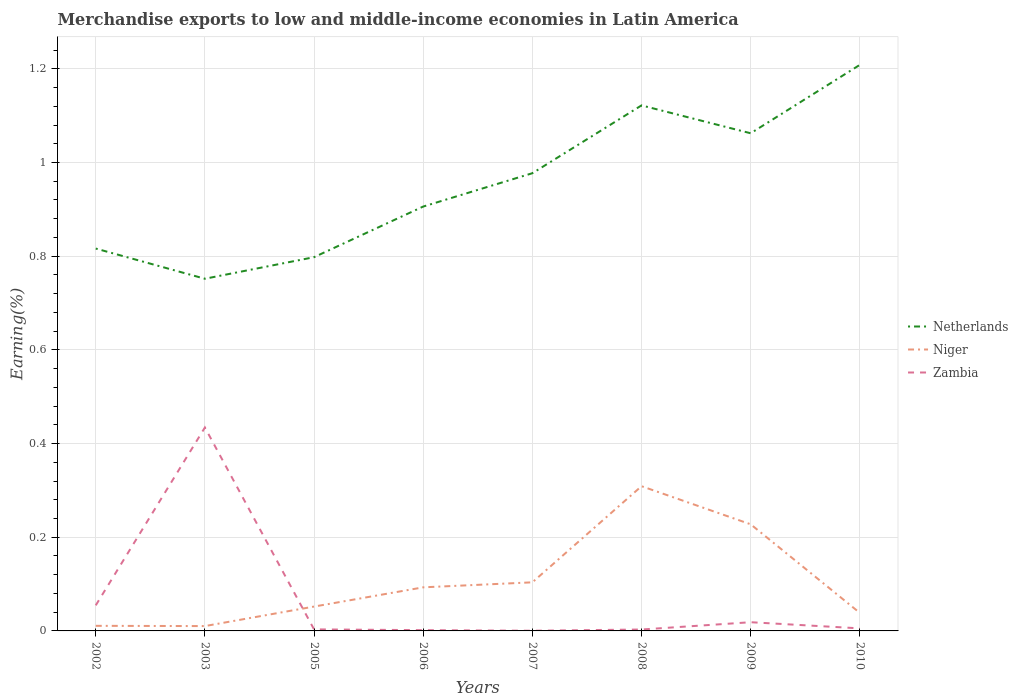Across all years, what is the maximum percentage of amount earned from merchandise exports in Zambia?
Provide a succinct answer. 0. What is the total percentage of amount earned from merchandise exports in Zambia in the graph?
Provide a short and direct response. 0.01. What is the difference between the highest and the second highest percentage of amount earned from merchandise exports in Netherlands?
Your answer should be compact. 0.46. What is the difference between the highest and the lowest percentage of amount earned from merchandise exports in Netherlands?
Your answer should be compact. 4. Is the percentage of amount earned from merchandise exports in Niger strictly greater than the percentage of amount earned from merchandise exports in Netherlands over the years?
Your response must be concise. Yes. How many lines are there?
Your answer should be very brief. 3. What is the difference between two consecutive major ticks on the Y-axis?
Give a very brief answer. 0.2. Does the graph contain grids?
Your answer should be compact. Yes. Where does the legend appear in the graph?
Offer a terse response. Center right. How are the legend labels stacked?
Offer a very short reply. Vertical. What is the title of the graph?
Your answer should be very brief. Merchandise exports to low and middle-income economies in Latin America. What is the label or title of the X-axis?
Make the answer very short. Years. What is the label or title of the Y-axis?
Offer a terse response. Earning(%). What is the Earning(%) in Netherlands in 2002?
Ensure brevity in your answer.  0.82. What is the Earning(%) in Niger in 2002?
Your response must be concise. 0.01. What is the Earning(%) in Zambia in 2002?
Ensure brevity in your answer.  0.05. What is the Earning(%) in Netherlands in 2003?
Offer a terse response. 0.75. What is the Earning(%) in Niger in 2003?
Ensure brevity in your answer.  0.01. What is the Earning(%) in Zambia in 2003?
Ensure brevity in your answer.  0.43. What is the Earning(%) in Netherlands in 2005?
Give a very brief answer. 0.8. What is the Earning(%) of Niger in 2005?
Ensure brevity in your answer.  0.05. What is the Earning(%) in Zambia in 2005?
Give a very brief answer. 0. What is the Earning(%) in Netherlands in 2006?
Your answer should be compact. 0.91. What is the Earning(%) in Niger in 2006?
Your answer should be compact. 0.09. What is the Earning(%) in Zambia in 2006?
Your answer should be compact. 0. What is the Earning(%) in Netherlands in 2007?
Make the answer very short. 0.98. What is the Earning(%) of Niger in 2007?
Ensure brevity in your answer.  0.1. What is the Earning(%) of Zambia in 2007?
Ensure brevity in your answer.  0. What is the Earning(%) in Netherlands in 2008?
Provide a short and direct response. 1.12. What is the Earning(%) in Niger in 2008?
Keep it short and to the point. 0.31. What is the Earning(%) of Zambia in 2008?
Ensure brevity in your answer.  0. What is the Earning(%) in Netherlands in 2009?
Offer a very short reply. 1.06. What is the Earning(%) of Niger in 2009?
Give a very brief answer. 0.23. What is the Earning(%) in Zambia in 2009?
Keep it short and to the point. 0.02. What is the Earning(%) in Netherlands in 2010?
Give a very brief answer. 1.21. What is the Earning(%) of Niger in 2010?
Your response must be concise. 0.04. What is the Earning(%) of Zambia in 2010?
Offer a terse response. 0.01. Across all years, what is the maximum Earning(%) of Netherlands?
Offer a very short reply. 1.21. Across all years, what is the maximum Earning(%) of Niger?
Give a very brief answer. 0.31. Across all years, what is the maximum Earning(%) in Zambia?
Make the answer very short. 0.43. Across all years, what is the minimum Earning(%) of Netherlands?
Provide a short and direct response. 0.75. Across all years, what is the minimum Earning(%) in Niger?
Offer a terse response. 0.01. Across all years, what is the minimum Earning(%) in Zambia?
Offer a very short reply. 0. What is the total Earning(%) in Netherlands in the graph?
Your answer should be compact. 7.64. What is the total Earning(%) in Niger in the graph?
Keep it short and to the point. 0.85. What is the total Earning(%) of Zambia in the graph?
Ensure brevity in your answer.  0.52. What is the difference between the Earning(%) of Netherlands in 2002 and that in 2003?
Provide a short and direct response. 0.06. What is the difference between the Earning(%) of Zambia in 2002 and that in 2003?
Offer a terse response. -0.38. What is the difference between the Earning(%) in Netherlands in 2002 and that in 2005?
Make the answer very short. 0.02. What is the difference between the Earning(%) of Niger in 2002 and that in 2005?
Ensure brevity in your answer.  -0.04. What is the difference between the Earning(%) of Zambia in 2002 and that in 2005?
Your response must be concise. 0.05. What is the difference between the Earning(%) in Netherlands in 2002 and that in 2006?
Make the answer very short. -0.09. What is the difference between the Earning(%) in Niger in 2002 and that in 2006?
Give a very brief answer. -0.08. What is the difference between the Earning(%) in Zambia in 2002 and that in 2006?
Keep it short and to the point. 0.05. What is the difference between the Earning(%) of Netherlands in 2002 and that in 2007?
Your answer should be very brief. -0.16. What is the difference between the Earning(%) of Niger in 2002 and that in 2007?
Your response must be concise. -0.09. What is the difference between the Earning(%) in Zambia in 2002 and that in 2007?
Your response must be concise. 0.05. What is the difference between the Earning(%) in Netherlands in 2002 and that in 2008?
Make the answer very short. -0.31. What is the difference between the Earning(%) in Niger in 2002 and that in 2008?
Keep it short and to the point. -0.3. What is the difference between the Earning(%) in Zambia in 2002 and that in 2008?
Your answer should be very brief. 0.05. What is the difference between the Earning(%) of Netherlands in 2002 and that in 2009?
Offer a terse response. -0.25. What is the difference between the Earning(%) in Niger in 2002 and that in 2009?
Keep it short and to the point. -0.22. What is the difference between the Earning(%) in Zambia in 2002 and that in 2009?
Your answer should be very brief. 0.04. What is the difference between the Earning(%) of Netherlands in 2002 and that in 2010?
Provide a succinct answer. -0.39. What is the difference between the Earning(%) of Niger in 2002 and that in 2010?
Provide a succinct answer. -0.03. What is the difference between the Earning(%) of Zambia in 2002 and that in 2010?
Offer a very short reply. 0.05. What is the difference between the Earning(%) in Netherlands in 2003 and that in 2005?
Ensure brevity in your answer.  -0.05. What is the difference between the Earning(%) of Niger in 2003 and that in 2005?
Make the answer very short. -0.04. What is the difference between the Earning(%) in Zambia in 2003 and that in 2005?
Provide a succinct answer. 0.43. What is the difference between the Earning(%) in Netherlands in 2003 and that in 2006?
Provide a succinct answer. -0.15. What is the difference between the Earning(%) in Niger in 2003 and that in 2006?
Ensure brevity in your answer.  -0.08. What is the difference between the Earning(%) in Zambia in 2003 and that in 2006?
Give a very brief answer. 0.43. What is the difference between the Earning(%) in Netherlands in 2003 and that in 2007?
Make the answer very short. -0.23. What is the difference between the Earning(%) of Niger in 2003 and that in 2007?
Your response must be concise. -0.09. What is the difference between the Earning(%) in Zambia in 2003 and that in 2007?
Give a very brief answer. 0.43. What is the difference between the Earning(%) of Netherlands in 2003 and that in 2008?
Your answer should be very brief. -0.37. What is the difference between the Earning(%) of Niger in 2003 and that in 2008?
Make the answer very short. -0.3. What is the difference between the Earning(%) of Zambia in 2003 and that in 2008?
Offer a terse response. 0.43. What is the difference between the Earning(%) of Netherlands in 2003 and that in 2009?
Your answer should be compact. -0.31. What is the difference between the Earning(%) of Niger in 2003 and that in 2009?
Give a very brief answer. -0.22. What is the difference between the Earning(%) in Zambia in 2003 and that in 2009?
Make the answer very short. 0.42. What is the difference between the Earning(%) in Netherlands in 2003 and that in 2010?
Offer a terse response. -0.46. What is the difference between the Earning(%) in Niger in 2003 and that in 2010?
Your answer should be compact. -0.03. What is the difference between the Earning(%) in Zambia in 2003 and that in 2010?
Your answer should be very brief. 0.43. What is the difference between the Earning(%) in Netherlands in 2005 and that in 2006?
Ensure brevity in your answer.  -0.11. What is the difference between the Earning(%) in Niger in 2005 and that in 2006?
Provide a succinct answer. -0.04. What is the difference between the Earning(%) in Zambia in 2005 and that in 2006?
Provide a succinct answer. 0. What is the difference between the Earning(%) of Netherlands in 2005 and that in 2007?
Your response must be concise. -0.18. What is the difference between the Earning(%) in Niger in 2005 and that in 2007?
Provide a succinct answer. -0.05. What is the difference between the Earning(%) in Zambia in 2005 and that in 2007?
Provide a short and direct response. 0. What is the difference between the Earning(%) in Netherlands in 2005 and that in 2008?
Provide a succinct answer. -0.32. What is the difference between the Earning(%) of Niger in 2005 and that in 2008?
Offer a terse response. -0.26. What is the difference between the Earning(%) of Netherlands in 2005 and that in 2009?
Provide a succinct answer. -0.26. What is the difference between the Earning(%) of Niger in 2005 and that in 2009?
Your answer should be compact. -0.18. What is the difference between the Earning(%) of Zambia in 2005 and that in 2009?
Keep it short and to the point. -0.02. What is the difference between the Earning(%) of Netherlands in 2005 and that in 2010?
Provide a succinct answer. -0.41. What is the difference between the Earning(%) in Niger in 2005 and that in 2010?
Ensure brevity in your answer.  0.01. What is the difference between the Earning(%) in Zambia in 2005 and that in 2010?
Provide a succinct answer. -0. What is the difference between the Earning(%) in Netherlands in 2006 and that in 2007?
Give a very brief answer. -0.07. What is the difference between the Earning(%) in Niger in 2006 and that in 2007?
Your answer should be compact. -0.01. What is the difference between the Earning(%) of Zambia in 2006 and that in 2007?
Your answer should be very brief. 0. What is the difference between the Earning(%) of Netherlands in 2006 and that in 2008?
Provide a short and direct response. -0.22. What is the difference between the Earning(%) in Niger in 2006 and that in 2008?
Provide a succinct answer. -0.22. What is the difference between the Earning(%) of Zambia in 2006 and that in 2008?
Give a very brief answer. -0. What is the difference between the Earning(%) of Netherlands in 2006 and that in 2009?
Provide a succinct answer. -0.16. What is the difference between the Earning(%) of Niger in 2006 and that in 2009?
Ensure brevity in your answer.  -0.13. What is the difference between the Earning(%) of Zambia in 2006 and that in 2009?
Make the answer very short. -0.02. What is the difference between the Earning(%) in Netherlands in 2006 and that in 2010?
Offer a terse response. -0.3. What is the difference between the Earning(%) in Niger in 2006 and that in 2010?
Provide a succinct answer. 0.05. What is the difference between the Earning(%) of Zambia in 2006 and that in 2010?
Offer a terse response. -0. What is the difference between the Earning(%) of Netherlands in 2007 and that in 2008?
Keep it short and to the point. -0.14. What is the difference between the Earning(%) of Niger in 2007 and that in 2008?
Make the answer very short. -0.21. What is the difference between the Earning(%) of Zambia in 2007 and that in 2008?
Offer a very short reply. -0. What is the difference between the Earning(%) in Netherlands in 2007 and that in 2009?
Your answer should be compact. -0.09. What is the difference between the Earning(%) of Niger in 2007 and that in 2009?
Your response must be concise. -0.12. What is the difference between the Earning(%) in Zambia in 2007 and that in 2009?
Provide a short and direct response. -0.02. What is the difference between the Earning(%) in Netherlands in 2007 and that in 2010?
Give a very brief answer. -0.23. What is the difference between the Earning(%) of Niger in 2007 and that in 2010?
Your answer should be compact. 0.07. What is the difference between the Earning(%) in Zambia in 2007 and that in 2010?
Your answer should be very brief. -0.01. What is the difference between the Earning(%) in Netherlands in 2008 and that in 2009?
Your answer should be compact. 0.06. What is the difference between the Earning(%) in Niger in 2008 and that in 2009?
Ensure brevity in your answer.  0.08. What is the difference between the Earning(%) in Zambia in 2008 and that in 2009?
Offer a very short reply. -0.02. What is the difference between the Earning(%) of Netherlands in 2008 and that in 2010?
Your answer should be very brief. -0.09. What is the difference between the Earning(%) of Niger in 2008 and that in 2010?
Your answer should be very brief. 0.27. What is the difference between the Earning(%) of Zambia in 2008 and that in 2010?
Offer a very short reply. -0. What is the difference between the Earning(%) of Netherlands in 2009 and that in 2010?
Provide a short and direct response. -0.15. What is the difference between the Earning(%) in Niger in 2009 and that in 2010?
Offer a very short reply. 0.19. What is the difference between the Earning(%) of Zambia in 2009 and that in 2010?
Your answer should be compact. 0.01. What is the difference between the Earning(%) of Netherlands in 2002 and the Earning(%) of Niger in 2003?
Provide a succinct answer. 0.81. What is the difference between the Earning(%) in Netherlands in 2002 and the Earning(%) in Zambia in 2003?
Keep it short and to the point. 0.38. What is the difference between the Earning(%) of Niger in 2002 and the Earning(%) of Zambia in 2003?
Provide a succinct answer. -0.42. What is the difference between the Earning(%) in Netherlands in 2002 and the Earning(%) in Niger in 2005?
Give a very brief answer. 0.76. What is the difference between the Earning(%) of Netherlands in 2002 and the Earning(%) of Zambia in 2005?
Provide a short and direct response. 0.81. What is the difference between the Earning(%) of Niger in 2002 and the Earning(%) of Zambia in 2005?
Give a very brief answer. 0.01. What is the difference between the Earning(%) in Netherlands in 2002 and the Earning(%) in Niger in 2006?
Make the answer very short. 0.72. What is the difference between the Earning(%) in Netherlands in 2002 and the Earning(%) in Zambia in 2006?
Your answer should be compact. 0.81. What is the difference between the Earning(%) of Niger in 2002 and the Earning(%) of Zambia in 2006?
Your response must be concise. 0.01. What is the difference between the Earning(%) of Netherlands in 2002 and the Earning(%) of Niger in 2007?
Provide a short and direct response. 0.71. What is the difference between the Earning(%) in Netherlands in 2002 and the Earning(%) in Zambia in 2007?
Ensure brevity in your answer.  0.82. What is the difference between the Earning(%) in Niger in 2002 and the Earning(%) in Zambia in 2007?
Offer a terse response. 0.01. What is the difference between the Earning(%) of Netherlands in 2002 and the Earning(%) of Niger in 2008?
Provide a short and direct response. 0.51. What is the difference between the Earning(%) in Netherlands in 2002 and the Earning(%) in Zambia in 2008?
Offer a terse response. 0.81. What is the difference between the Earning(%) in Niger in 2002 and the Earning(%) in Zambia in 2008?
Keep it short and to the point. 0.01. What is the difference between the Earning(%) in Netherlands in 2002 and the Earning(%) in Niger in 2009?
Give a very brief answer. 0.59. What is the difference between the Earning(%) of Netherlands in 2002 and the Earning(%) of Zambia in 2009?
Offer a very short reply. 0.8. What is the difference between the Earning(%) in Niger in 2002 and the Earning(%) in Zambia in 2009?
Offer a terse response. -0.01. What is the difference between the Earning(%) in Netherlands in 2002 and the Earning(%) in Zambia in 2010?
Your response must be concise. 0.81. What is the difference between the Earning(%) of Niger in 2002 and the Earning(%) of Zambia in 2010?
Offer a very short reply. 0.01. What is the difference between the Earning(%) in Netherlands in 2003 and the Earning(%) in Niger in 2005?
Offer a terse response. 0.7. What is the difference between the Earning(%) in Netherlands in 2003 and the Earning(%) in Zambia in 2005?
Provide a succinct answer. 0.75. What is the difference between the Earning(%) of Niger in 2003 and the Earning(%) of Zambia in 2005?
Make the answer very short. 0.01. What is the difference between the Earning(%) of Netherlands in 2003 and the Earning(%) of Niger in 2006?
Your answer should be very brief. 0.66. What is the difference between the Earning(%) in Netherlands in 2003 and the Earning(%) in Zambia in 2006?
Make the answer very short. 0.75. What is the difference between the Earning(%) in Niger in 2003 and the Earning(%) in Zambia in 2006?
Your answer should be very brief. 0.01. What is the difference between the Earning(%) in Netherlands in 2003 and the Earning(%) in Niger in 2007?
Keep it short and to the point. 0.65. What is the difference between the Earning(%) of Netherlands in 2003 and the Earning(%) of Zambia in 2007?
Keep it short and to the point. 0.75. What is the difference between the Earning(%) in Niger in 2003 and the Earning(%) in Zambia in 2007?
Give a very brief answer. 0.01. What is the difference between the Earning(%) of Netherlands in 2003 and the Earning(%) of Niger in 2008?
Ensure brevity in your answer.  0.44. What is the difference between the Earning(%) of Netherlands in 2003 and the Earning(%) of Zambia in 2008?
Your answer should be very brief. 0.75. What is the difference between the Earning(%) of Niger in 2003 and the Earning(%) of Zambia in 2008?
Ensure brevity in your answer.  0.01. What is the difference between the Earning(%) of Netherlands in 2003 and the Earning(%) of Niger in 2009?
Your answer should be very brief. 0.52. What is the difference between the Earning(%) in Netherlands in 2003 and the Earning(%) in Zambia in 2009?
Provide a succinct answer. 0.73. What is the difference between the Earning(%) in Niger in 2003 and the Earning(%) in Zambia in 2009?
Provide a short and direct response. -0.01. What is the difference between the Earning(%) of Netherlands in 2003 and the Earning(%) of Niger in 2010?
Ensure brevity in your answer.  0.71. What is the difference between the Earning(%) in Netherlands in 2003 and the Earning(%) in Zambia in 2010?
Give a very brief answer. 0.75. What is the difference between the Earning(%) in Niger in 2003 and the Earning(%) in Zambia in 2010?
Keep it short and to the point. 0. What is the difference between the Earning(%) of Netherlands in 2005 and the Earning(%) of Niger in 2006?
Provide a succinct answer. 0.7. What is the difference between the Earning(%) in Netherlands in 2005 and the Earning(%) in Zambia in 2006?
Give a very brief answer. 0.8. What is the difference between the Earning(%) of Niger in 2005 and the Earning(%) of Zambia in 2006?
Your answer should be very brief. 0.05. What is the difference between the Earning(%) of Netherlands in 2005 and the Earning(%) of Niger in 2007?
Provide a succinct answer. 0.69. What is the difference between the Earning(%) in Netherlands in 2005 and the Earning(%) in Zambia in 2007?
Offer a very short reply. 0.8. What is the difference between the Earning(%) in Niger in 2005 and the Earning(%) in Zambia in 2007?
Ensure brevity in your answer.  0.05. What is the difference between the Earning(%) of Netherlands in 2005 and the Earning(%) of Niger in 2008?
Your answer should be very brief. 0.49. What is the difference between the Earning(%) of Netherlands in 2005 and the Earning(%) of Zambia in 2008?
Offer a very short reply. 0.79. What is the difference between the Earning(%) in Niger in 2005 and the Earning(%) in Zambia in 2008?
Keep it short and to the point. 0.05. What is the difference between the Earning(%) of Netherlands in 2005 and the Earning(%) of Niger in 2009?
Your response must be concise. 0.57. What is the difference between the Earning(%) in Netherlands in 2005 and the Earning(%) in Zambia in 2009?
Your answer should be very brief. 0.78. What is the difference between the Earning(%) in Niger in 2005 and the Earning(%) in Zambia in 2009?
Your answer should be compact. 0.03. What is the difference between the Earning(%) in Netherlands in 2005 and the Earning(%) in Niger in 2010?
Offer a very short reply. 0.76. What is the difference between the Earning(%) of Netherlands in 2005 and the Earning(%) of Zambia in 2010?
Give a very brief answer. 0.79. What is the difference between the Earning(%) of Niger in 2005 and the Earning(%) of Zambia in 2010?
Your answer should be very brief. 0.05. What is the difference between the Earning(%) in Netherlands in 2006 and the Earning(%) in Niger in 2007?
Your answer should be compact. 0.8. What is the difference between the Earning(%) in Netherlands in 2006 and the Earning(%) in Zambia in 2007?
Offer a very short reply. 0.91. What is the difference between the Earning(%) in Niger in 2006 and the Earning(%) in Zambia in 2007?
Your answer should be very brief. 0.09. What is the difference between the Earning(%) of Netherlands in 2006 and the Earning(%) of Niger in 2008?
Keep it short and to the point. 0.6. What is the difference between the Earning(%) of Netherlands in 2006 and the Earning(%) of Zambia in 2008?
Provide a succinct answer. 0.9. What is the difference between the Earning(%) in Niger in 2006 and the Earning(%) in Zambia in 2008?
Your answer should be very brief. 0.09. What is the difference between the Earning(%) of Netherlands in 2006 and the Earning(%) of Niger in 2009?
Make the answer very short. 0.68. What is the difference between the Earning(%) of Netherlands in 2006 and the Earning(%) of Zambia in 2009?
Offer a terse response. 0.89. What is the difference between the Earning(%) in Niger in 2006 and the Earning(%) in Zambia in 2009?
Provide a short and direct response. 0.07. What is the difference between the Earning(%) in Netherlands in 2006 and the Earning(%) in Niger in 2010?
Give a very brief answer. 0.87. What is the difference between the Earning(%) in Netherlands in 2006 and the Earning(%) in Zambia in 2010?
Provide a succinct answer. 0.9. What is the difference between the Earning(%) in Niger in 2006 and the Earning(%) in Zambia in 2010?
Provide a short and direct response. 0.09. What is the difference between the Earning(%) in Netherlands in 2007 and the Earning(%) in Niger in 2008?
Your answer should be very brief. 0.67. What is the difference between the Earning(%) in Netherlands in 2007 and the Earning(%) in Zambia in 2008?
Make the answer very short. 0.97. What is the difference between the Earning(%) in Niger in 2007 and the Earning(%) in Zambia in 2008?
Give a very brief answer. 0.1. What is the difference between the Earning(%) in Netherlands in 2007 and the Earning(%) in Niger in 2009?
Your response must be concise. 0.75. What is the difference between the Earning(%) of Netherlands in 2007 and the Earning(%) of Zambia in 2009?
Give a very brief answer. 0.96. What is the difference between the Earning(%) in Niger in 2007 and the Earning(%) in Zambia in 2009?
Offer a terse response. 0.09. What is the difference between the Earning(%) in Netherlands in 2007 and the Earning(%) in Niger in 2010?
Your answer should be compact. 0.94. What is the difference between the Earning(%) in Netherlands in 2007 and the Earning(%) in Zambia in 2010?
Provide a short and direct response. 0.97. What is the difference between the Earning(%) in Niger in 2007 and the Earning(%) in Zambia in 2010?
Keep it short and to the point. 0.1. What is the difference between the Earning(%) of Netherlands in 2008 and the Earning(%) of Niger in 2009?
Your answer should be very brief. 0.89. What is the difference between the Earning(%) of Netherlands in 2008 and the Earning(%) of Zambia in 2009?
Your response must be concise. 1.1. What is the difference between the Earning(%) of Niger in 2008 and the Earning(%) of Zambia in 2009?
Make the answer very short. 0.29. What is the difference between the Earning(%) of Netherlands in 2008 and the Earning(%) of Niger in 2010?
Offer a very short reply. 1.08. What is the difference between the Earning(%) of Netherlands in 2008 and the Earning(%) of Zambia in 2010?
Provide a short and direct response. 1.12. What is the difference between the Earning(%) in Niger in 2008 and the Earning(%) in Zambia in 2010?
Your response must be concise. 0.3. What is the difference between the Earning(%) of Netherlands in 2009 and the Earning(%) of Niger in 2010?
Give a very brief answer. 1.02. What is the difference between the Earning(%) of Netherlands in 2009 and the Earning(%) of Zambia in 2010?
Your answer should be compact. 1.06. What is the difference between the Earning(%) in Niger in 2009 and the Earning(%) in Zambia in 2010?
Offer a terse response. 0.22. What is the average Earning(%) in Netherlands per year?
Your answer should be compact. 0.96. What is the average Earning(%) of Niger per year?
Your response must be concise. 0.11. What is the average Earning(%) of Zambia per year?
Your answer should be very brief. 0.07. In the year 2002, what is the difference between the Earning(%) in Netherlands and Earning(%) in Niger?
Your answer should be very brief. 0.81. In the year 2002, what is the difference between the Earning(%) in Netherlands and Earning(%) in Zambia?
Your answer should be compact. 0.76. In the year 2002, what is the difference between the Earning(%) of Niger and Earning(%) of Zambia?
Provide a succinct answer. -0.04. In the year 2003, what is the difference between the Earning(%) in Netherlands and Earning(%) in Niger?
Give a very brief answer. 0.74. In the year 2003, what is the difference between the Earning(%) of Netherlands and Earning(%) of Zambia?
Offer a very short reply. 0.32. In the year 2003, what is the difference between the Earning(%) in Niger and Earning(%) in Zambia?
Give a very brief answer. -0.42. In the year 2005, what is the difference between the Earning(%) in Netherlands and Earning(%) in Niger?
Provide a succinct answer. 0.75. In the year 2005, what is the difference between the Earning(%) of Netherlands and Earning(%) of Zambia?
Make the answer very short. 0.79. In the year 2005, what is the difference between the Earning(%) in Niger and Earning(%) in Zambia?
Your response must be concise. 0.05. In the year 2006, what is the difference between the Earning(%) in Netherlands and Earning(%) in Niger?
Your answer should be very brief. 0.81. In the year 2006, what is the difference between the Earning(%) of Netherlands and Earning(%) of Zambia?
Provide a short and direct response. 0.9. In the year 2006, what is the difference between the Earning(%) in Niger and Earning(%) in Zambia?
Provide a short and direct response. 0.09. In the year 2007, what is the difference between the Earning(%) of Netherlands and Earning(%) of Niger?
Make the answer very short. 0.87. In the year 2007, what is the difference between the Earning(%) in Netherlands and Earning(%) in Zambia?
Provide a succinct answer. 0.98. In the year 2007, what is the difference between the Earning(%) in Niger and Earning(%) in Zambia?
Offer a terse response. 0.1. In the year 2008, what is the difference between the Earning(%) of Netherlands and Earning(%) of Niger?
Provide a short and direct response. 0.81. In the year 2008, what is the difference between the Earning(%) of Netherlands and Earning(%) of Zambia?
Give a very brief answer. 1.12. In the year 2008, what is the difference between the Earning(%) of Niger and Earning(%) of Zambia?
Keep it short and to the point. 0.31. In the year 2009, what is the difference between the Earning(%) in Netherlands and Earning(%) in Niger?
Ensure brevity in your answer.  0.83. In the year 2009, what is the difference between the Earning(%) in Netherlands and Earning(%) in Zambia?
Ensure brevity in your answer.  1.04. In the year 2009, what is the difference between the Earning(%) in Niger and Earning(%) in Zambia?
Give a very brief answer. 0.21. In the year 2010, what is the difference between the Earning(%) in Netherlands and Earning(%) in Niger?
Your answer should be compact. 1.17. In the year 2010, what is the difference between the Earning(%) in Netherlands and Earning(%) in Zambia?
Offer a terse response. 1.2. In the year 2010, what is the difference between the Earning(%) of Niger and Earning(%) of Zambia?
Ensure brevity in your answer.  0.03. What is the ratio of the Earning(%) of Netherlands in 2002 to that in 2003?
Make the answer very short. 1.09. What is the ratio of the Earning(%) in Niger in 2002 to that in 2003?
Your answer should be compact. 1.05. What is the ratio of the Earning(%) of Zambia in 2002 to that in 2003?
Your response must be concise. 0.13. What is the ratio of the Earning(%) in Netherlands in 2002 to that in 2005?
Make the answer very short. 1.02. What is the ratio of the Earning(%) in Niger in 2002 to that in 2005?
Ensure brevity in your answer.  0.21. What is the ratio of the Earning(%) in Zambia in 2002 to that in 2005?
Keep it short and to the point. 16.54. What is the ratio of the Earning(%) of Netherlands in 2002 to that in 2006?
Offer a very short reply. 0.9. What is the ratio of the Earning(%) of Niger in 2002 to that in 2006?
Ensure brevity in your answer.  0.12. What is the ratio of the Earning(%) in Zambia in 2002 to that in 2006?
Your response must be concise. 32.91. What is the ratio of the Earning(%) in Netherlands in 2002 to that in 2007?
Keep it short and to the point. 0.84. What is the ratio of the Earning(%) in Niger in 2002 to that in 2007?
Give a very brief answer. 0.1. What is the ratio of the Earning(%) of Zambia in 2002 to that in 2007?
Provide a short and direct response. 139.6. What is the ratio of the Earning(%) in Netherlands in 2002 to that in 2008?
Make the answer very short. 0.73. What is the ratio of the Earning(%) of Niger in 2002 to that in 2008?
Provide a short and direct response. 0.04. What is the ratio of the Earning(%) of Zambia in 2002 to that in 2008?
Your answer should be compact. 18.16. What is the ratio of the Earning(%) in Netherlands in 2002 to that in 2009?
Keep it short and to the point. 0.77. What is the ratio of the Earning(%) in Niger in 2002 to that in 2009?
Offer a very short reply. 0.05. What is the ratio of the Earning(%) in Zambia in 2002 to that in 2009?
Your answer should be compact. 2.94. What is the ratio of the Earning(%) of Netherlands in 2002 to that in 2010?
Your answer should be compact. 0.68. What is the ratio of the Earning(%) in Niger in 2002 to that in 2010?
Keep it short and to the point. 0.28. What is the ratio of the Earning(%) of Zambia in 2002 to that in 2010?
Your answer should be very brief. 10.04. What is the ratio of the Earning(%) of Netherlands in 2003 to that in 2005?
Keep it short and to the point. 0.94. What is the ratio of the Earning(%) of Niger in 2003 to that in 2005?
Your response must be concise. 0.2. What is the ratio of the Earning(%) in Zambia in 2003 to that in 2005?
Provide a short and direct response. 131.59. What is the ratio of the Earning(%) in Netherlands in 2003 to that in 2006?
Provide a succinct answer. 0.83. What is the ratio of the Earning(%) in Zambia in 2003 to that in 2006?
Your answer should be compact. 261.82. What is the ratio of the Earning(%) in Netherlands in 2003 to that in 2007?
Make the answer very short. 0.77. What is the ratio of the Earning(%) in Niger in 2003 to that in 2007?
Provide a succinct answer. 0.1. What is the ratio of the Earning(%) of Zambia in 2003 to that in 2007?
Your answer should be compact. 1110.73. What is the ratio of the Earning(%) in Netherlands in 2003 to that in 2008?
Offer a terse response. 0.67. What is the ratio of the Earning(%) in Niger in 2003 to that in 2008?
Give a very brief answer. 0.03. What is the ratio of the Earning(%) of Zambia in 2003 to that in 2008?
Your answer should be very brief. 144.46. What is the ratio of the Earning(%) of Netherlands in 2003 to that in 2009?
Keep it short and to the point. 0.71. What is the ratio of the Earning(%) in Niger in 2003 to that in 2009?
Your response must be concise. 0.05. What is the ratio of the Earning(%) in Zambia in 2003 to that in 2009?
Your answer should be very brief. 23.36. What is the ratio of the Earning(%) of Netherlands in 2003 to that in 2010?
Your response must be concise. 0.62. What is the ratio of the Earning(%) in Niger in 2003 to that in 2010?
Provide a succinct answer. 0.27. What is the ratio of the Earning(%) of Zambia in 2003 to that in 2010?
Provide a succinct answer. 79.9. What is the ratio of the Earning(%) of Netherlands in 2005 to that in 2006?
Your answer should be compact. 0.88. What is the ratio of the Earning(%) of Niger in 2005 to that in 2006?
Your answer should be very brief. 0.56. What is the ratio of the Earning(%) in Zambia in 2005 to that in 2006?
Keep it short and to the point. 1.99. What is the ratio of the Earning(%) of Netherlands in 2005 to that in 2007?
Your response must be concise. 0.82. What is the ratio of the Earning(%) in Niger in 2005 to that in 2007?
Give a very brief answer. 0.5. What is the ratio of the Earning(%) in Zambia in 2005 to that in 2007?
Your response must be concise. 8.44. What is the ratio of the Earning(%) in Netherlands in 2005 to that in 2008?
Give a very brief answer. 0.71. What is the ratio of the Earning(%) of Niger in 2005 to that in 2008?
Give a very brief answer. 0.17. What is the ratio of the Earning(%) in Zambia in 2005 to that in 2008?
Make the answer very short. 1.1. What is the ratio of the Earning(%) of Netherlands in 2005 to that in 2009?
Provide a short and direct response. 0.75. What is the ratio of the Earning(%) of Niger in 2005 to that in 2009?
Offer a terse response. 0.23. What is the ratio of the Earning(%) of Zambia in 2005 to that in 2009?
Provide a succinct answer. 0.18. What is the ratio of the Earning(%) of Netherlands in 2005 to that in 2010?
Offer a very short reply. 0.66. What is the ratio of the Earning(%) in Niger in 2005 to that in 2010?
Your answer should be very brief. 1.35. What is the ratio of the Earning(%) of Zambia in 2005 to that in 2010?
Keep it short and to the point. 0.61. What is the ratio of the Earning(%) in Netherlands in 2006 to that in 2007?
Provide a succinct answer. 0.93. What is the ratio of the Earning(%) of Niger in 2006 to that in 2007?
Offer a very short reply. 0.9. What is the ratio of the Earning(%) of Zambia in 2006 to that in 2007?
Provide a succinct answer. 4.24. What is the ratio of the Earning(%) of Netherlands in 2006 to that in 2008?
Provide a succinct answer. 0.81. What is the ratio of the Earning(%) of Niger in 2006 to that in 2008?
Make the answer very short. 0.3. What is the ratio of the Earning(%) in Zambia in 2006 to that in 2008?
Offer a very short reply. 0.55. What is the ratio of the Earning(%) of Netherlands in 2006 to that in 2009?
Provide a short and direct response. 0.85. What is the ratio of the Earning(%) in Niger in 2006 to that in 2009?
Provide a short and direct response. 0.41. What is the ratio of the Earning(%) of Zambia in 2006 to that in 2009?
Your answer should be compact. 0.09. What is the ratio of the Earning(%) of Netherlands in 2006 to that in 2010?
Give a very brief answer. 0.75. What is the ratio of the Earning(%) in Niger in 2006 to that in 2010?
Offer a very short reply. 2.42. What is the ratio of the Earning(%) in Zambia in 2006 to that in 2010?
Your answer should be very brief. 0.31. What is the ratio of the Earning(%) in Netherlands in 2007 to that in 2008?
Your answer should be compact. 0.87. What is the ratio of the Earning(%) of Niger in 2007 to that in 2008?
Provide a short and direct response. 0.34. What is the ratio of the Earning(%) of Zambia in 2007 to that in 2008?
Provide a succinct answer. 0.13. What is the ratio of the Earning(%) of Netherlands in 2007 to that in 2009?
Provide a succinct answer. 0.92. What is the ratio of the Earning(%) in Niger in 2007 to that in 2009?
Offer a very short reply. 0.46. What is the ratio of the Earning(%) of Zambia in 2007 to that in 2009?
Provide a succinct answer. 0.02. What is the ratio of the Earning(%) in Netherlands in 2007 to that in 2010?
Give a very brief answer. 0.81. What is the ratio of the Earning(%) in Niger in 2007 to that in 2010?
Keep it short and to the point. 2.7. What is the ratio of the Earning(%) in Zambia in 2007 to that in 2010?
Your answer should be compact. 0.07. What is the ratio of the Earning(%) of Netherlands in 2008 to that in 2009?
Make the answer very short. 1.06. What is the ratio of the Earning(%) in Niger in 2008 to that in 2009?
Make the answer very short. 1.36. What is the ratio of the Earning(%) of Zambia in 2008 to that in 2009?
Your response must be concise. 0.16. What is the ratio of the Earning(%) of Netherlands in 2008 to that in 2010?
Offer a terse response. 0.93. What is the ratio of the Earning(%) of Niger in 2008 to that in 2010?
Provide a short and direct response. 8.03. What is the ratio of the Earning(%) in Zambia in 2008 to that in 2010?
Your answer should be very brief. 0.55. What is the ratio of the Earning(%) in Netherlands in 2009 to that in 2010?
Provide a short and direct response. 0.88. What is the ratio of the Earning(%) in Niger in 2009 to that in 2010?
Give a very brief answer. 5.91. What is the ratio of the Earning(%) of Zambia in 2009 to that in 2010?
Your response must be concise. 3.42. What is the difference between the highest and the second highest Earning(%) in Netherlands?
Offer a very short reply. 0.09. What is the difference between the highest and the second highest Earning(%) in Niger?
Give a very brief answer. 0.08. What is the difference between the highest and the second highest Earning(%) of Zambia?
Ensure brevity in your answer.  0.38. What is the difference between the highest and the lowest Earning(%) in Netherlands?
Ensure brevity in your answer.  0.46. What is the difference between the highest and the lowest Earning(%) of Niger?
Your answer should be very brief. 0.3. What is the difference between the highest and the lowest Earning(%) in Zambia?
Your response must be concise. 0.43. 